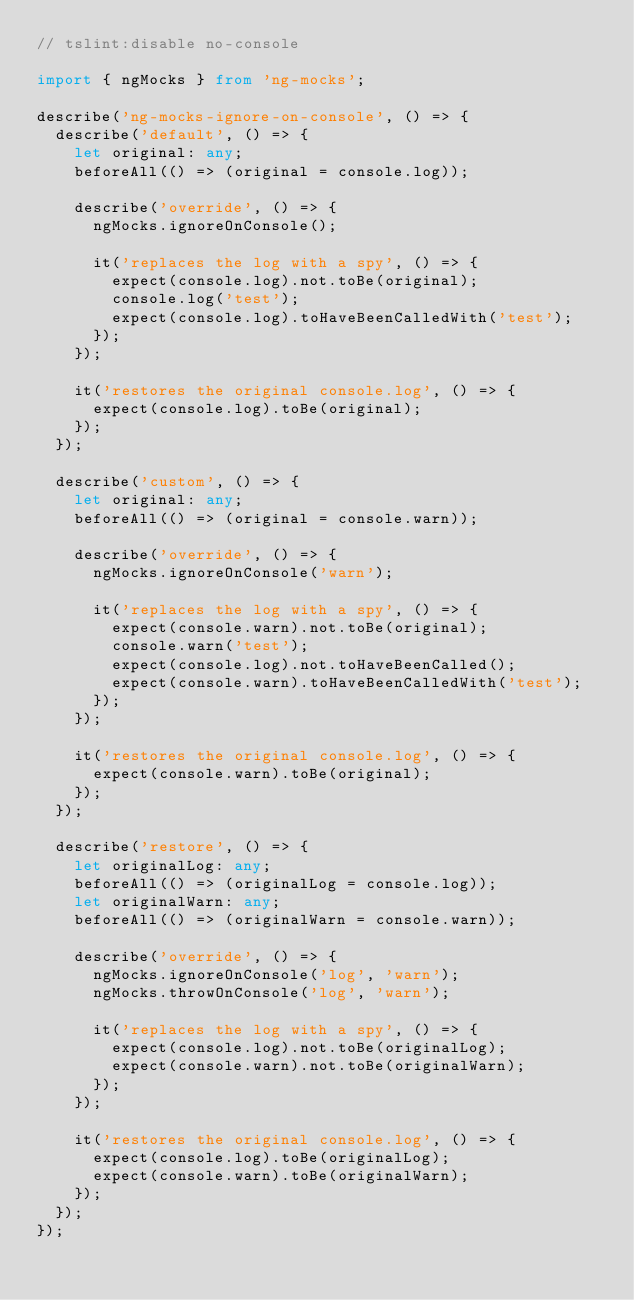Convert code to text. <code><loc_0><loc_0><loc_500><loc_500><_TypeScript_>// tslint:disable no-console

import { ngMocks } from 'ng-mocks';

describe('ng-mocks-ignore-on-console', () => {
  describe('default', () => {
    let original: any;
    beforeAll(() => (original = console.log));

    describe('override', () => {
      ngMocks.ignoreOnConsole();

      it('replaces the log with a spy', () => {
        expect(console.log).not.toBe(original);
        console.log('test');
        expect(console.log).toHaveBeenCalledWith('test');
      });
    });

    it('restores the original console.log', () => {
      expect(console.log).toBe(original);
    });
  });

  describe('custom', () => {
    let original: any;
    beforeAll(() => (original = console.warn));

    describe('override', () => {
      ngMocks.ignoreOnConsole('warn');

      it('replaces the log with a spy', () => {
        expect(console.warn).not.toBe(original);
        console.warn('test');
        expect(console.log).not.toHaveBeenCalled();
        expect(console.warn).toHaveBeenCalledWith('test');
      });
    });

    it('restores the original console.log', () => {
      expect(console.warn).toBe(original);
    });
  });

  describe('restore', () => {
    let originalLog: any;
    beforeAll(() => (originalLog = console.log));
    let originalWarn: any;
    beforeAll(() => (originalWarn = console.warn));

    describe('override', () => {
      ngMocks.ignoreOnConsole('log', 'warn');
      ngMocks.throwOnConsole('log', 'warn');

      it('replaces the log with a spy', () => {
        expect(console.log).not.toBe(originalLog);
        expect(console.warn).not.toBe(originalWarn);
      });
    });

    it('restores the original console.log', () => {
      expect(console.log).toBe(originalLog);
      expect(console.warn).toBe(originalWarn);
    });
  });
});
</code> 